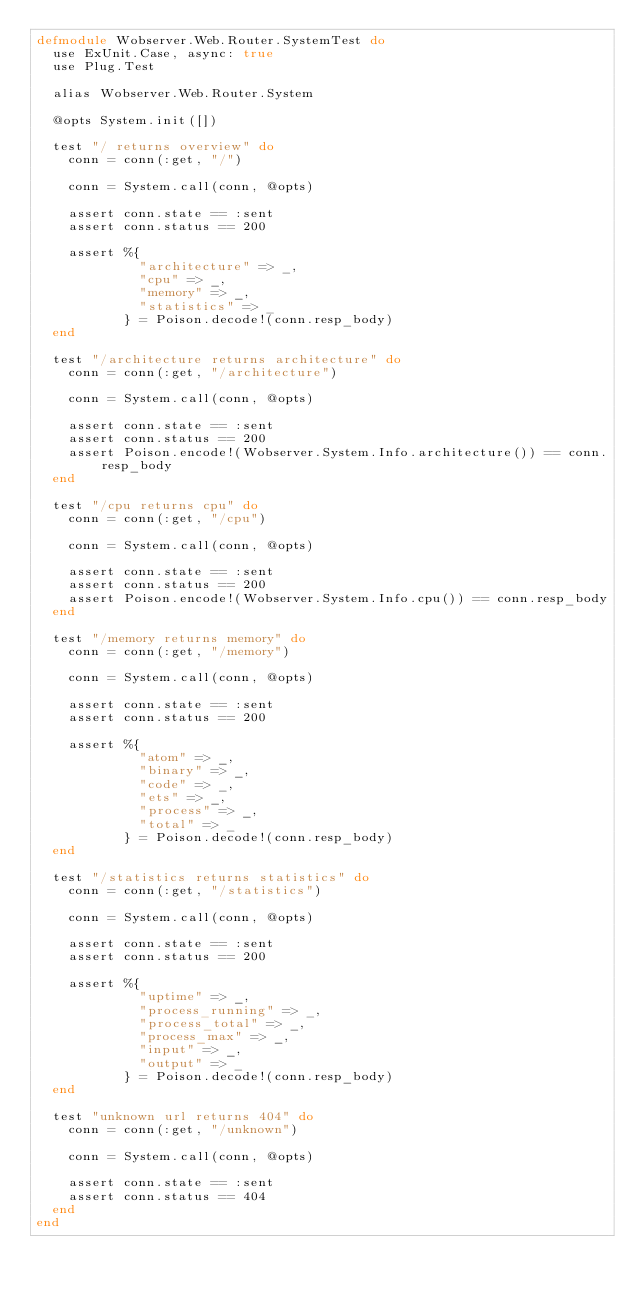Convert code to text. <code><loc_0><loc_0><loc_500><loc_500><_Elixir_>defmodule Wobserver.Web.Router.SystemTest do
  use ExUnit.Case, async: true
  use Plug.Test

  alias Wobserver.Web.Router.System

  @opts System.init([])

  test "/ returns overview" do
    conn = conn(:get, "/")

    conn = System.call(conn, @opts)

    assert conn.state == :sent
    assert conn.status == 200

    assert %{
             "architecture" => _,
             "cpu" => _,
             "memory" => _,
             "statistics" => _
           } = Poison.decode!(conn.resp_body)
  end

  test "/architecture returns architecture" do
    conn = conn(:get, "/architecture")

    conn = System.call(conn, @opts)

    assert conn.state == :sent
    assert conn.status == 200
    assert Poison.encode!(Wobserver.System.Info.architecture()) == conn.resp_body
  end

  test "/cpu returns cpu" do
    conn = conn(:get, "/cpu")

    conn = System.call(conn, @opts)

    assert conn.state == :sent
    assert conn.status == 200
    assert Poison.encode!(Wobserver.System.Info.cpu()) == conn.resp_body
  end

  test "/memory returns memory" do
    conn = conn(:get, "/memory")

    conn = System.call(conn, @opts)

    assert conn.state == :sent
    assert conn.status == 200

    assert %{
             "atom" => _,
             "binary" => _,
             "code" => _,
             "ets" => _,
             "process" => _,
             "total" => _
           } = Poison.decode!(conn.resp_body)
  end

  test "/statistics returns statistics" do
    conn = conn(:get, "/statistics")

    conn = System.call(conn, @opts)

    assert conn.state == :sent
    assert conn.status == 200

    assert %{
             "uptime" => _,
             "process_running" => _,
             "process_total" => _,
             "process_max" => _,
             "input" => _,
             "output" => _
           } = Poison.decode!(conn.resp_body)
  end

  test "unknown url returns 404" do
    conn = conn(:get, "/unknown")

    conn = System.call(conn, @opts)

    assert conn.state == :sent
    assert conn.status == 404
  end
end
</code> 